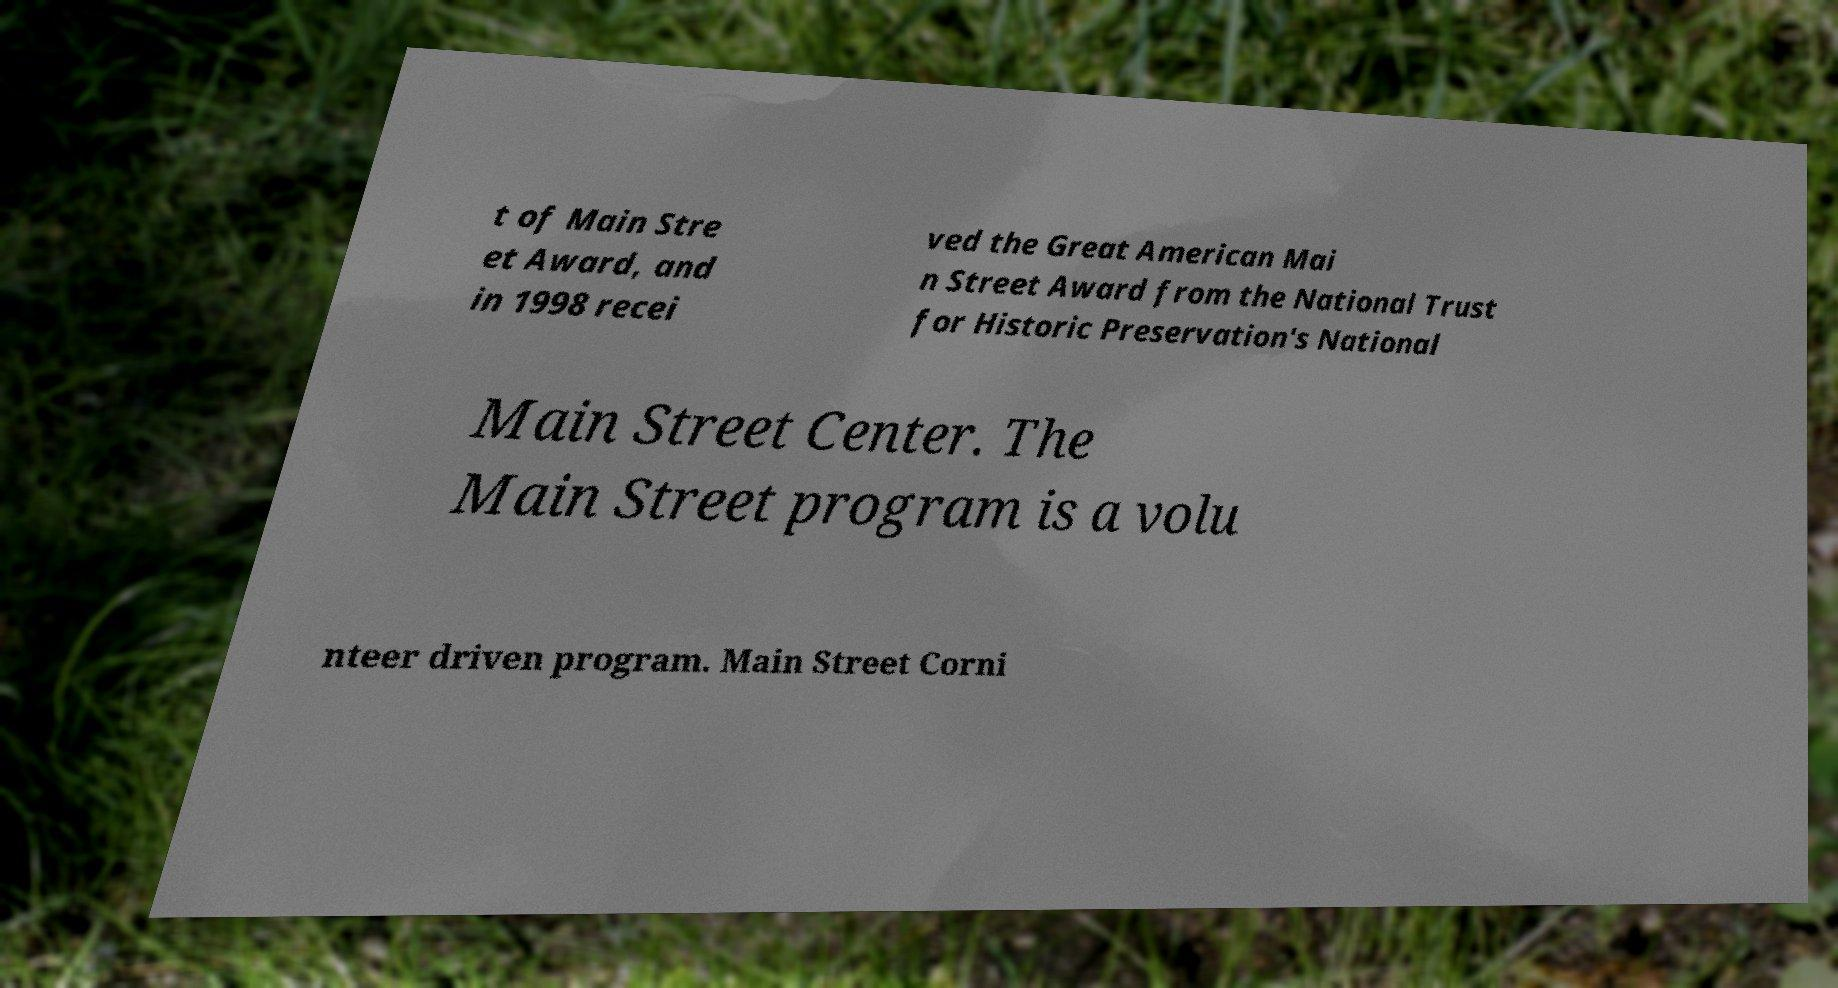Please read and relay the text visible in this image. What does it say? t of Main Stre et Award, and in 1998 recei ved the Great American Mai n Street Award from the National Trust for Historic Preservation's National Main Street Center. The Main Street program is a volu nteer driven program. Main Street Corni 